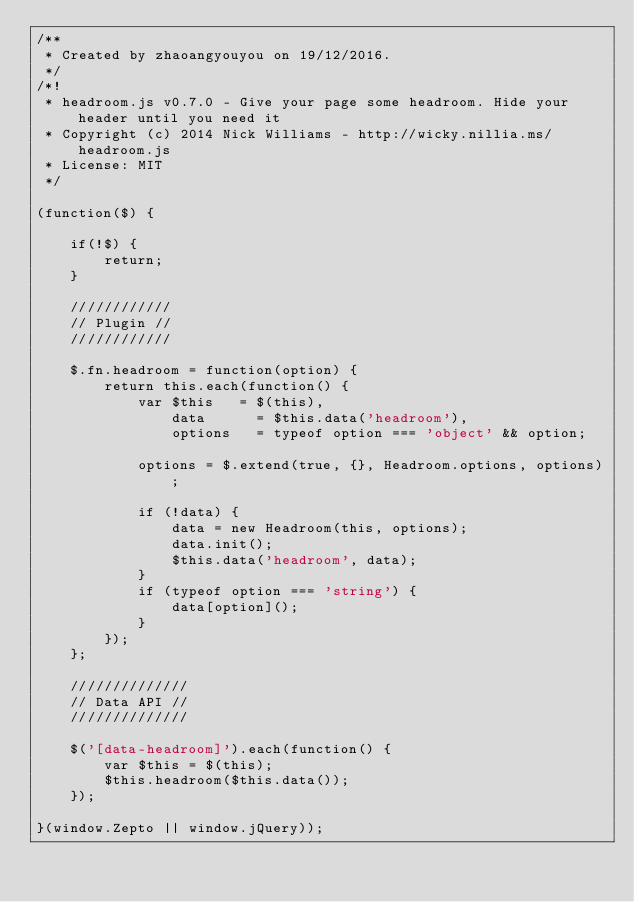Convert code to text. <code><loc_0><loc_0><loc_500><loc_500><_JavaScript_>/**
 * Created by zhaoangyouyou on 19/12/2016.
 */
/*!
 * headroom.js v0.7.0 - Give your page some headroom. Hide your header until you need it
 * Copyright (c) 2014 Nick Williams - http://wicky.nillia.ms/headroom.js
 * License: MIT
 */

(function($) {

    if(!$) {
        return;
    }

    ////////////
    // Plugin //
    ////////////

    $.fn.headroom = function(option) {
        return this.each(function() {
            var $this   = $(this),
                data      = $this.data('headroom'),
                options   = typeof option === 'object' && option;

            options = $.extend(true, {}, Headroom.options, options);

            if (!data) {
                data = new Headroom(this, options);
                data.init();
                $this.data('headroom', data);
            }
            if (typeof option === 'string') {
                data[option]();
            }
        });
    };

    //////////////
    // Data API //
    //////////////

    $('[data-headroom]').each(function() {
        var $this = $(this);
        $this.headroom($this.data());
    });

}(window.Zepto || window.jQuery));</code> 